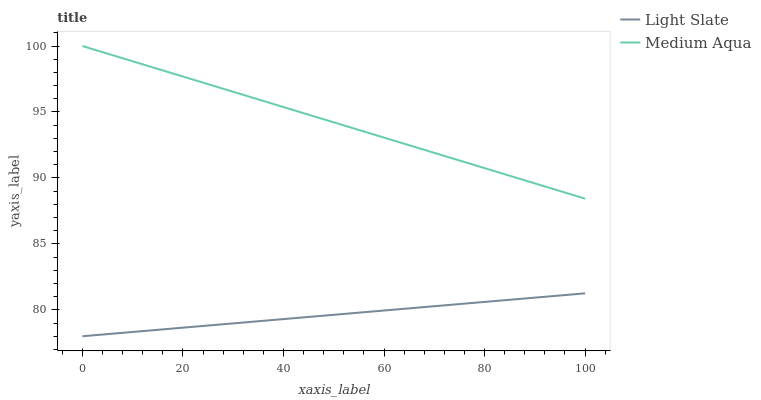Does Light Slate have the minimum area under the curve?
Answer yes or no. Yes. Does Medium Aqua have the maximum area under the curve?
Answer yes or no. Yes. Does Medium Aqua have the minimum area under the curve?
Answer yes or no. No. Is Light Slate the smoothest?
Answer yes or no. Yes. Is Medium Aqua the roughest?
Answer yes or no. Yes. Is Medium Aqua the smoothest?
Answer yes or no. No. Does Light Slate have the lowest value?
Answer yes or no. Yes. Does Medium Aqua have the lowest value?
Answer yes or no. No. Does Medium Aqua have the highest value?
Answer yes or no. Yes. Is Light Slate less than Medium Aqua?
Answer yes or no. Yes. Is Medium Aqua greater than Light Slate?
Answer yes or no. Yes. Does Light Slate intersect Medium Aqua?
Answer yes or no. No. 